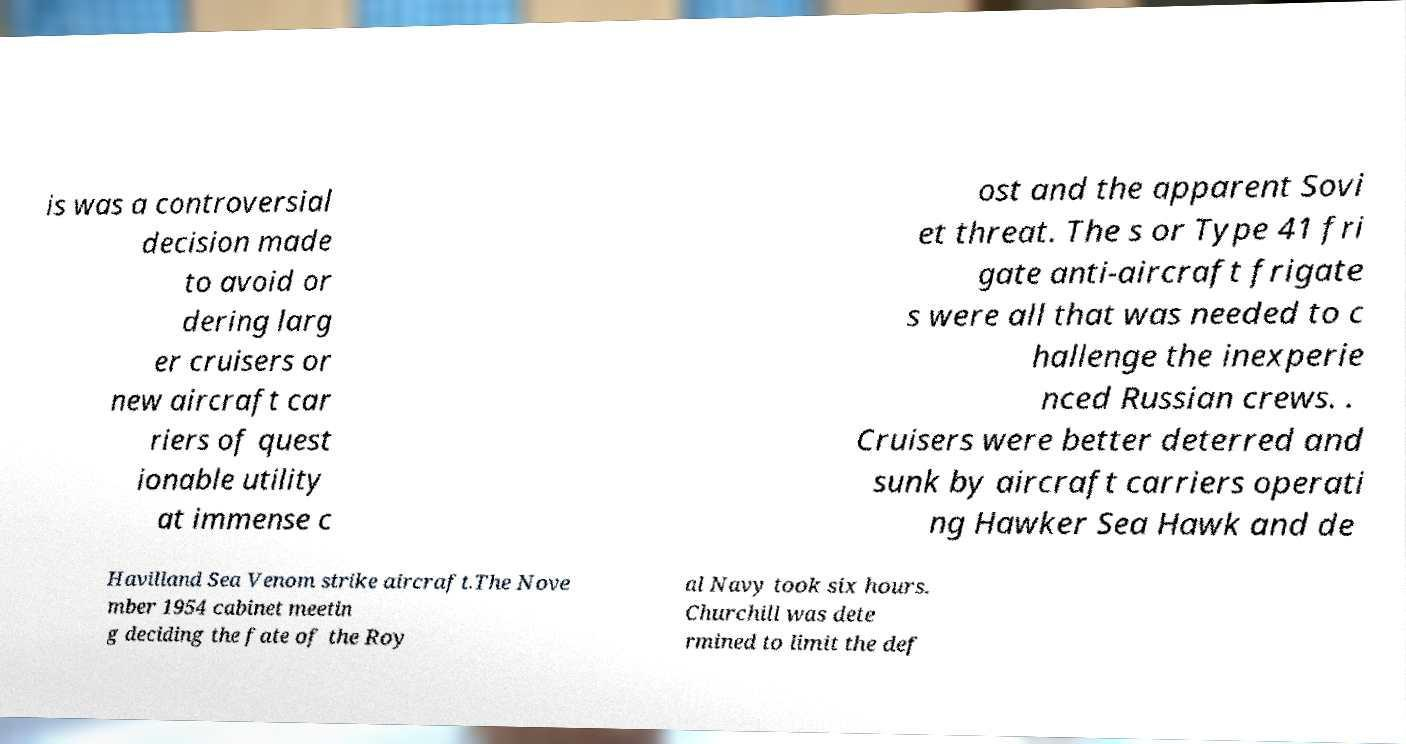Could you extract and type out the text from this image? is was a controversial decision made to avoid or dering larg er cruisers or new aircraft car riers of quest ionable utility at immense c ost and the apparent Sovi et threat. The s or Type 41 fri gate anti-aircraft frigate s were all that was needed to c hallenge the inexperie nced Russian crews. . Cruisers were better deterred and sunk by aircraft carriers operati ng Hawker Sea Hawk and de Havilland Sea Venom strike aircraft.The Nove mber 1954 cabinet meetin g deciding the fate of the Roy al Navy took six hours. Churchill was dete rmined to limit the def 